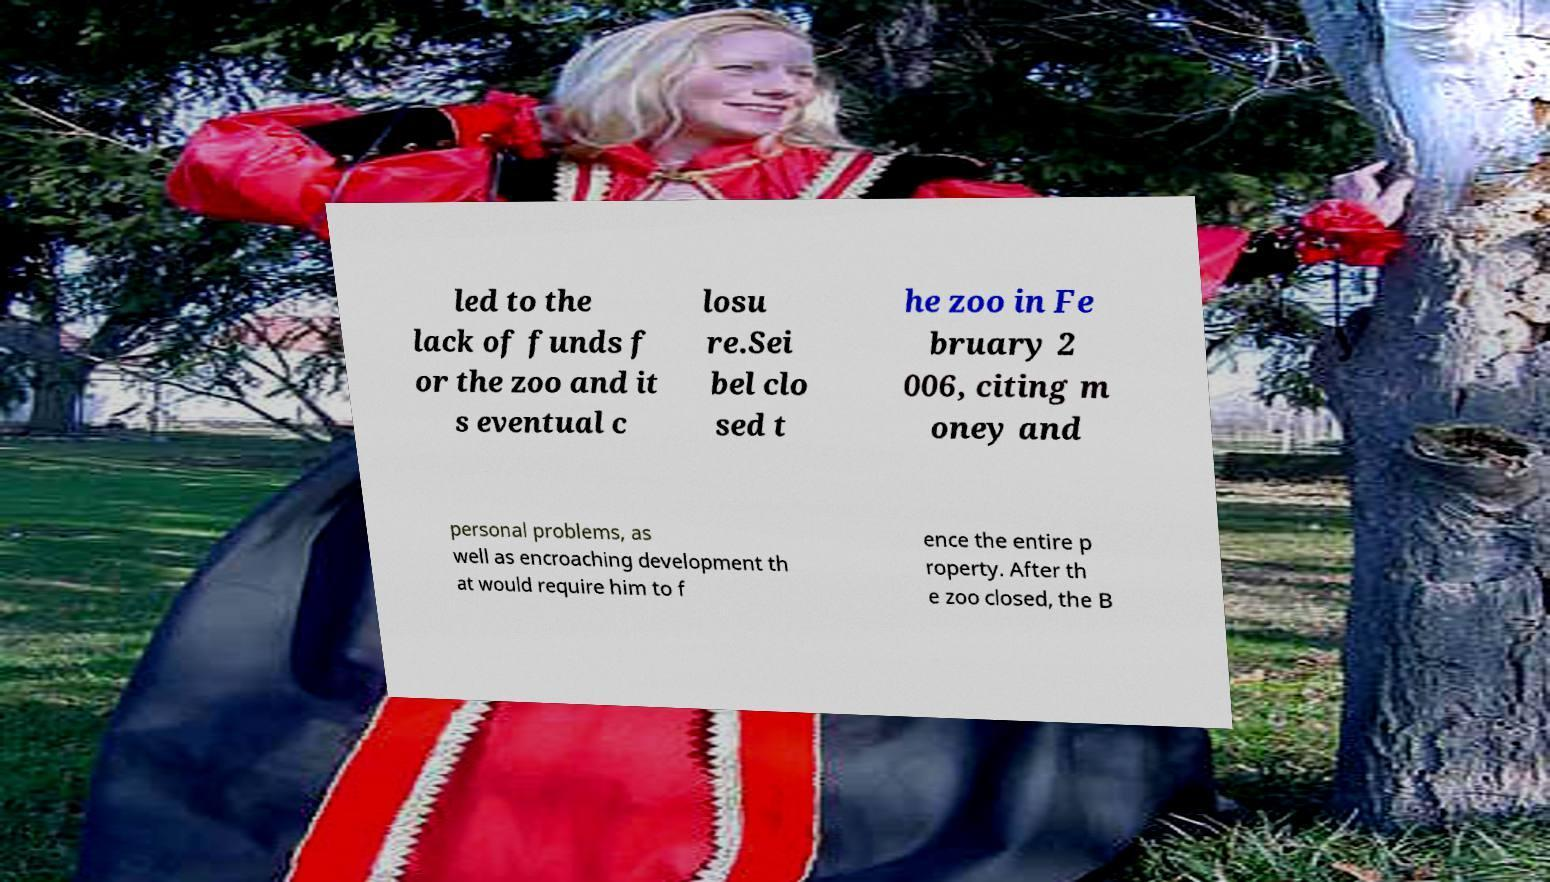Could you extract and type out the text from this image? led to the lack of funds f or the zoo and it s eventual c losu re.Sei bel clo sed t he zoo in Fe bruary 2 006, citing m oney and personal problems, as well as encroaching development th at would require him to f ence the entire p roperty. After th e zoo closed, the B 